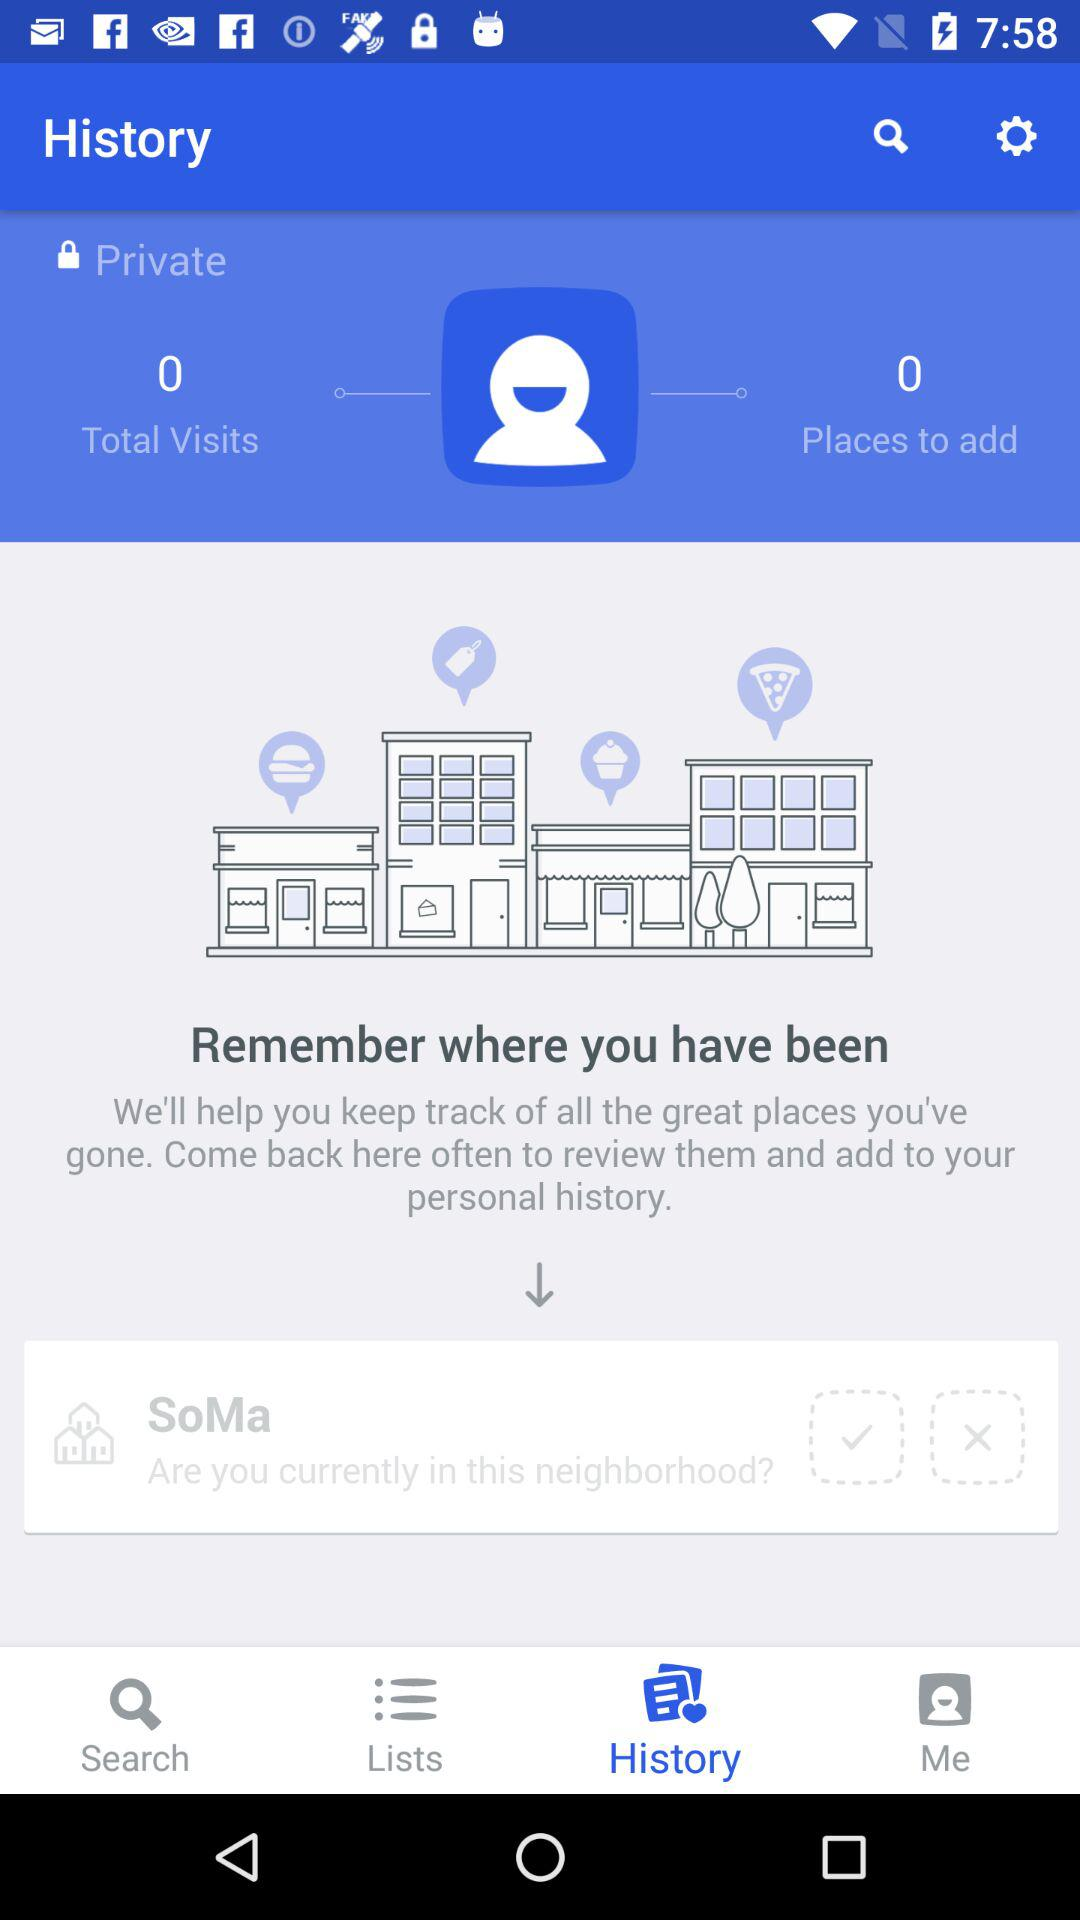How many places are there to add? There are 0 places to add. 